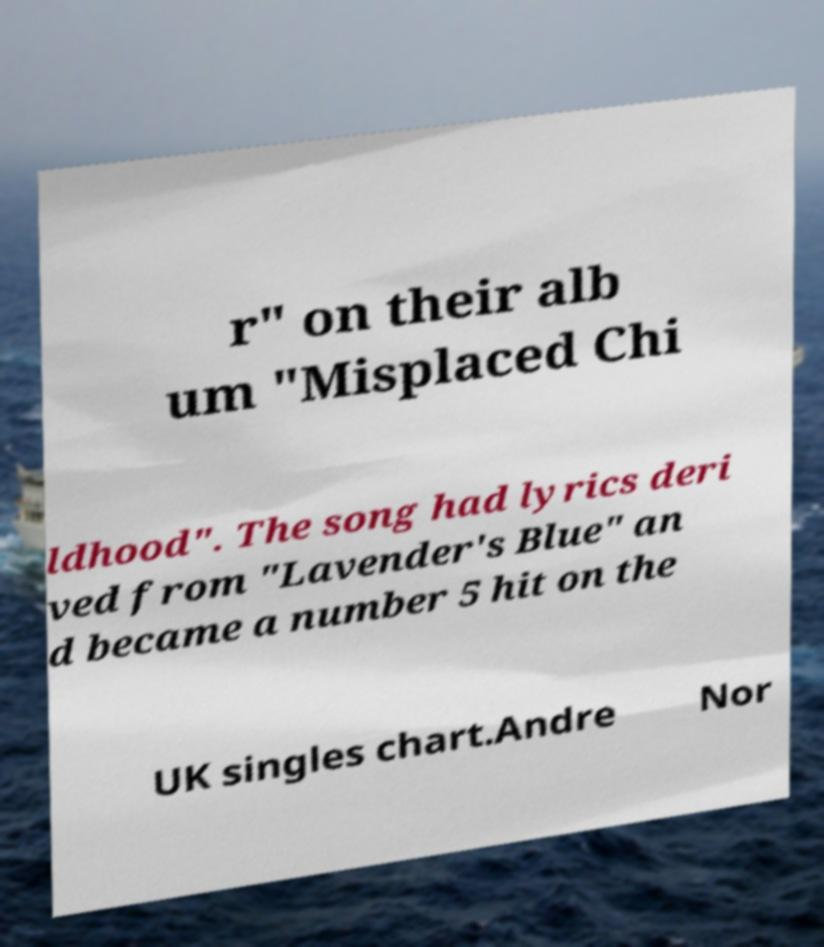There's text embedded in this image that I need extracted. Can you transcribe it verbatim? r" on their alb um "Misplaced Chi ldhood". The song had lyrics deri ved from "Lavender's Blue" an d became a number 5 hit on the UK singles chart.Andre Nor 